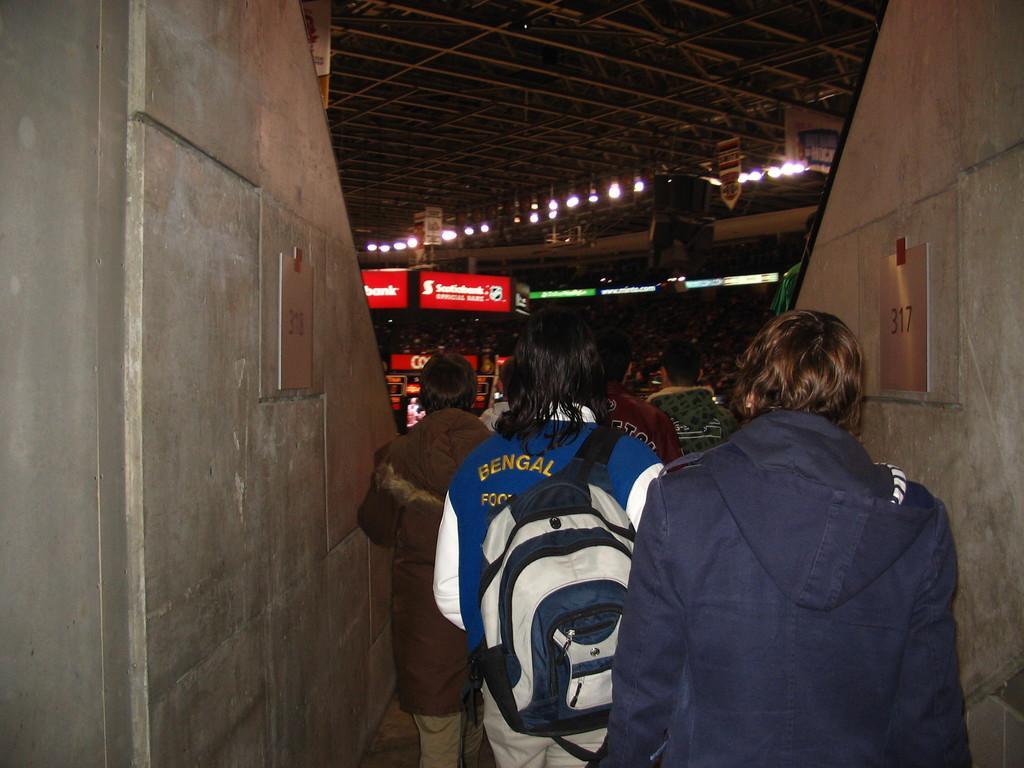Please provide a concise description of this image. In this picture we can see a group of boys moving in the stadium. In the front we can see red banner boards. In the front bottom side we can see two concrete walls. 